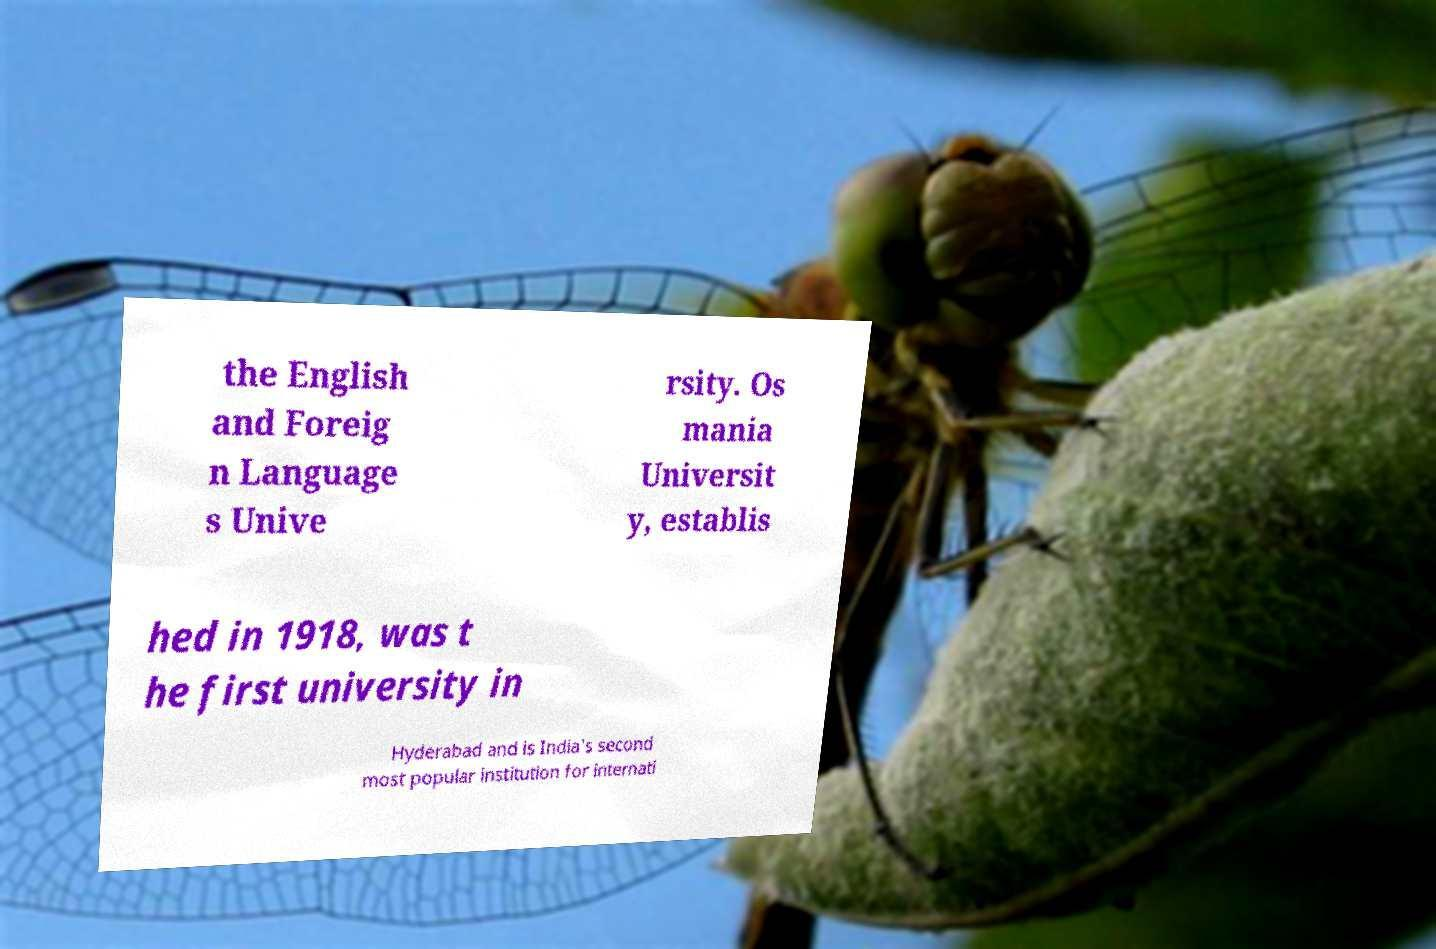Could you extract and type out the text from this image? the English and Foreig n Language s Unive rsity. Os mania Universit y, establis hed in 1918, was t he first university in Hyderabad and is India's second most popular institution for internati 